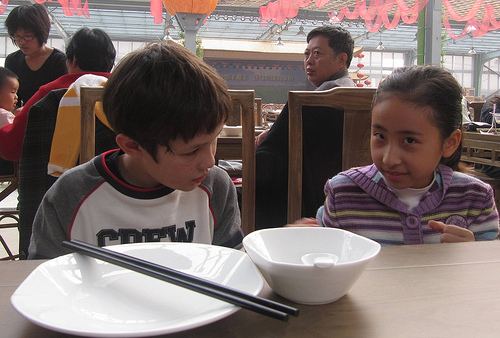<image>
Is there a woman on the shirt? No. The woman is not positioned on the shirt. They may be near each other, but the woman is not supported by or resting on top of the shirt. Is the chair behind the chopsticks? Yes. From this viewpoint, the chair is positioned behind the chopsticks, with the chopsticks partially or fully occluding the chair. Is there a boy to the right of the girl? Yes. From this viewpoint, the boy is positioned to the right side relative to the girl. 